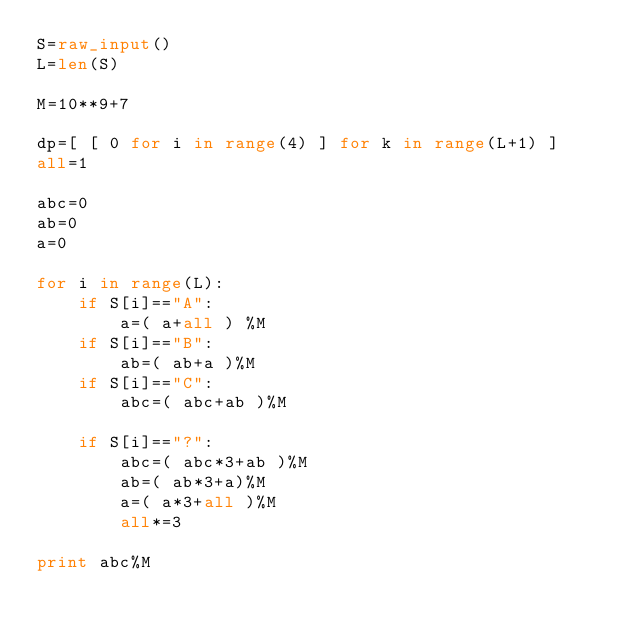Convert code to text. <code><loc_0><loc_0><loc_500><loc_500><_Python_>S=raw_input()
L=len(S)

M=10**9+7

dp=[ [ 0 for i in range(4) ] for k in range(L+1) ]
all=1

abc=0
ab=0
a=0

for i in range(L):
	if S[i]=="A":
		a=( a+all ) %M
	if S[i]=="B":
		ab=( ab+a )%M
	if S[i]=="C":
		abc=( abc+ab )%M

	if S[i]=="?":
		abc=( abc*3+ab )%M
		ab=( ab*3+a)%M
		a=( a*3+all )%M
		all*=3

print abc%M
</code> 